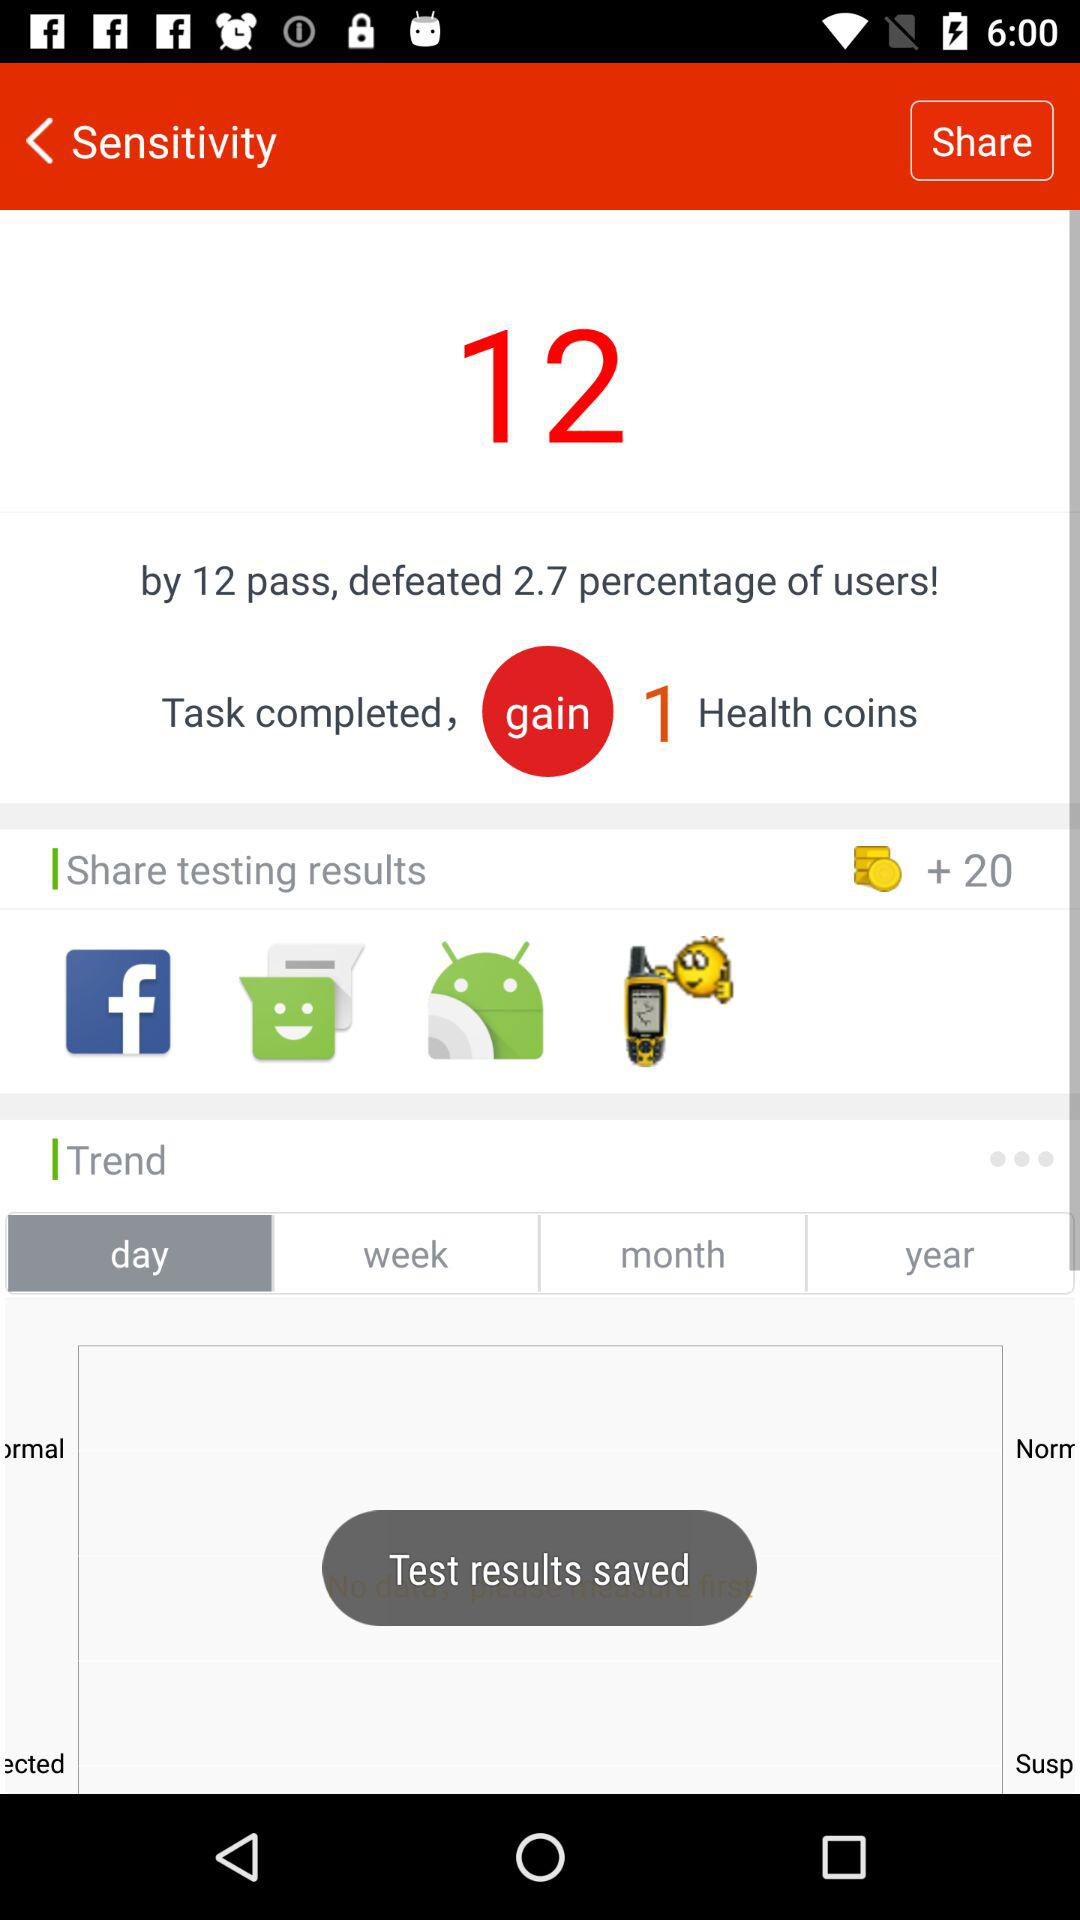What percentage of users were defeated? There are 2.7 percent of users who have been defeated. 